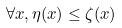Convert formula to latex. <formula><loc_0><loc_0><loc_500><loc_500>\forall x , \eta ( x ) \leq \zeta ( x )</formula> 